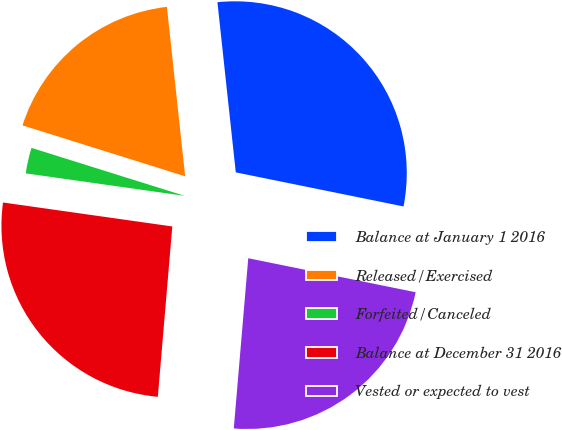Convert chart. <chart><loc_0><loc_0><loc_500><loc_500><pie_chart><fcel>Balance at January 1 2016<fcel>Released/Exercised<fcel>Forfeited/Canceled<fcel>Balance at December 31 2016<fcel>Vested or expected to vest<nl><fcel>29.9%<fcel>18.46%<fcel>2.59%<fcel>25.89%<fcel>23.16%<nl></chart> 